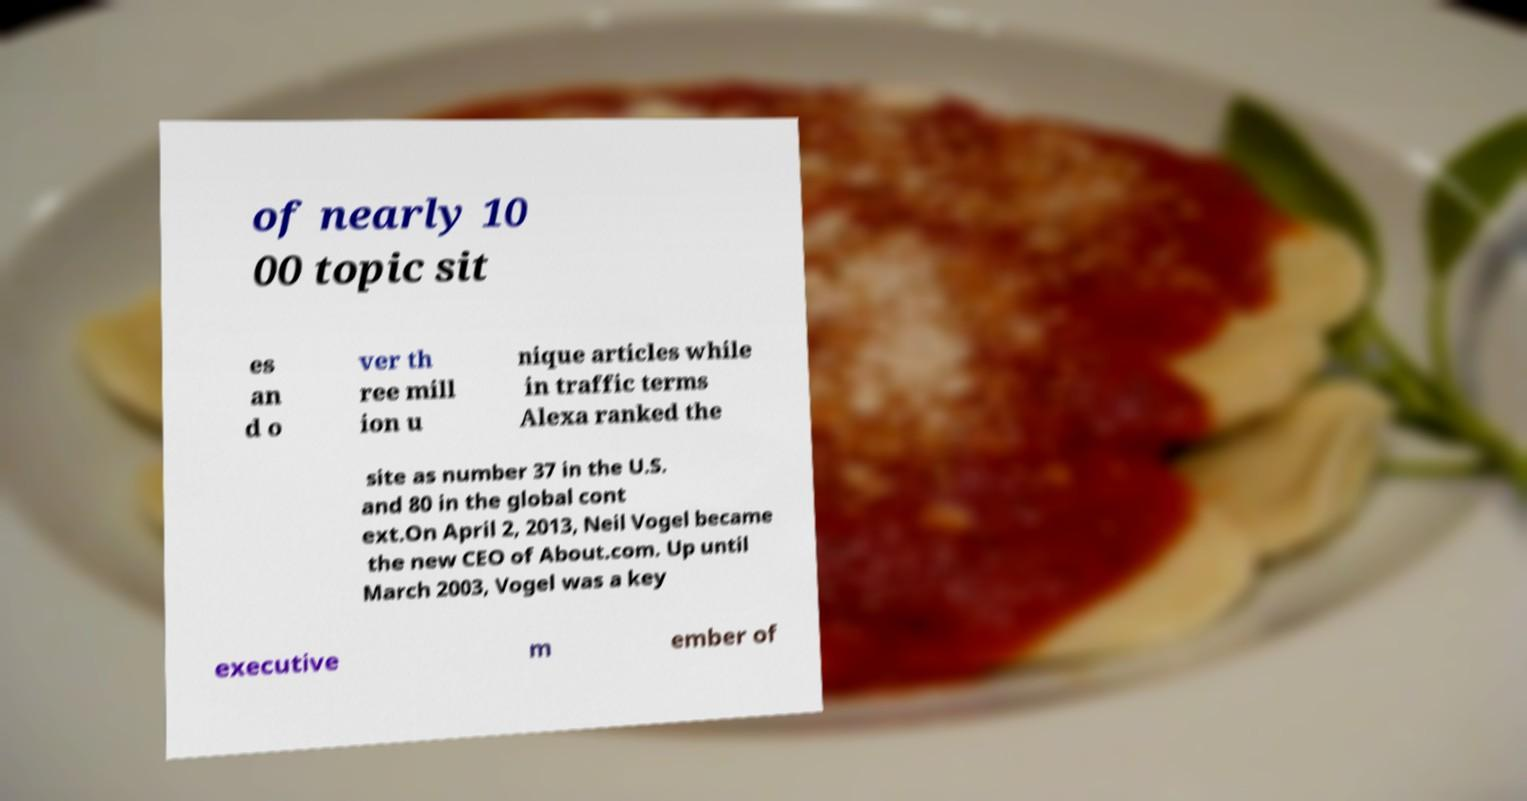Can you read and provide the text displayed in the image?This photo seems to have some interesting text. Can you extract and type it out for me? of nearly 10 00 topic sit es an d o ver th ree mill ion u nique articles while in traffic terms Alexa ranked the site as number 37 in the U.S. and 80 in the global cont ext.On April 2, 2013, Neil Vogel became the new CEO of About.com. Up until March 2003, Vogel was a key executive m ember of 